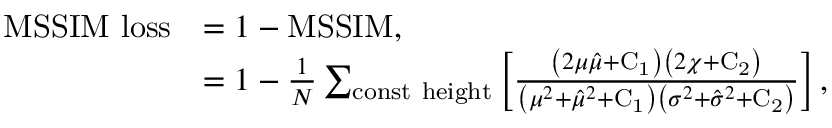<formula> <loc_0><loc_0><loc_500><loc_500>\begin{array} { r l } { M S S I M l o s s } & { = 1 - M S S I M , } \\ & { = 1 - \frac { 1 } { N } \sum _ { c o n s t h e i g h t } \left [ \frac { \left ( 2 \mu \hat { \mu } + C _ { 1 } \right ) \left ( 2 \chi + C _ { 2 } \right ) } { \left ( \mu ^ { 2 } + \hat { \mu } ^ { 2 } + C _ { 1 } \right ) \left ( \sigma ^ { 2 } + \hat { \sigma } ^ { 2 } + C _ { 2 } \right ) } \right ] , } \end{array}</formula> 